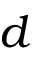<formula> <loc_0><loc_0><loc_500><loc_500>d</formula> 